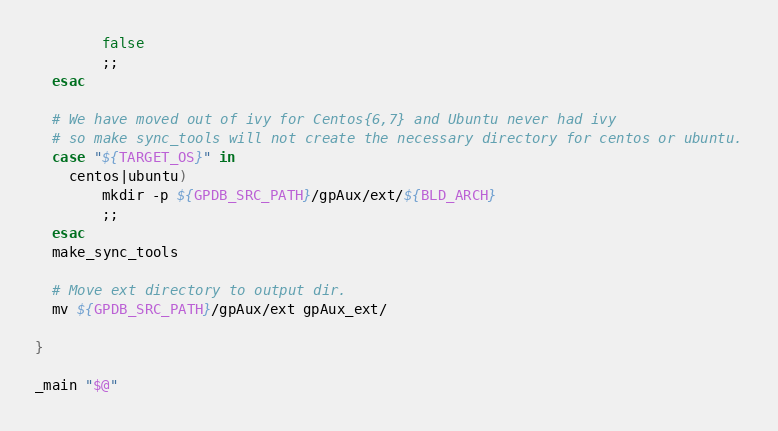<code> <loc_0><loc_0><loc_500><loc_500><_Bash_>        false
        ;;
  esac

  # We have moved out of ivy for Centos{6,7} and Ubuntu never had ivy
  # so make sync_tools will not create the necessary directory for centos or ubuntu.
  case "${TARGET_OS}" in
    centos|ubuntu)
        mkdir -p ${GPDB_SRC_PATH}/gpAux/ext/${BLD_ARCH}
        ;;
  esac
  make_sync_tools

  # Move ext directory to output dir.
  mv ${GPDB_SRC_PATH}/gpAux/ext gpAux_ext/

}

_main "$@"
</code> 